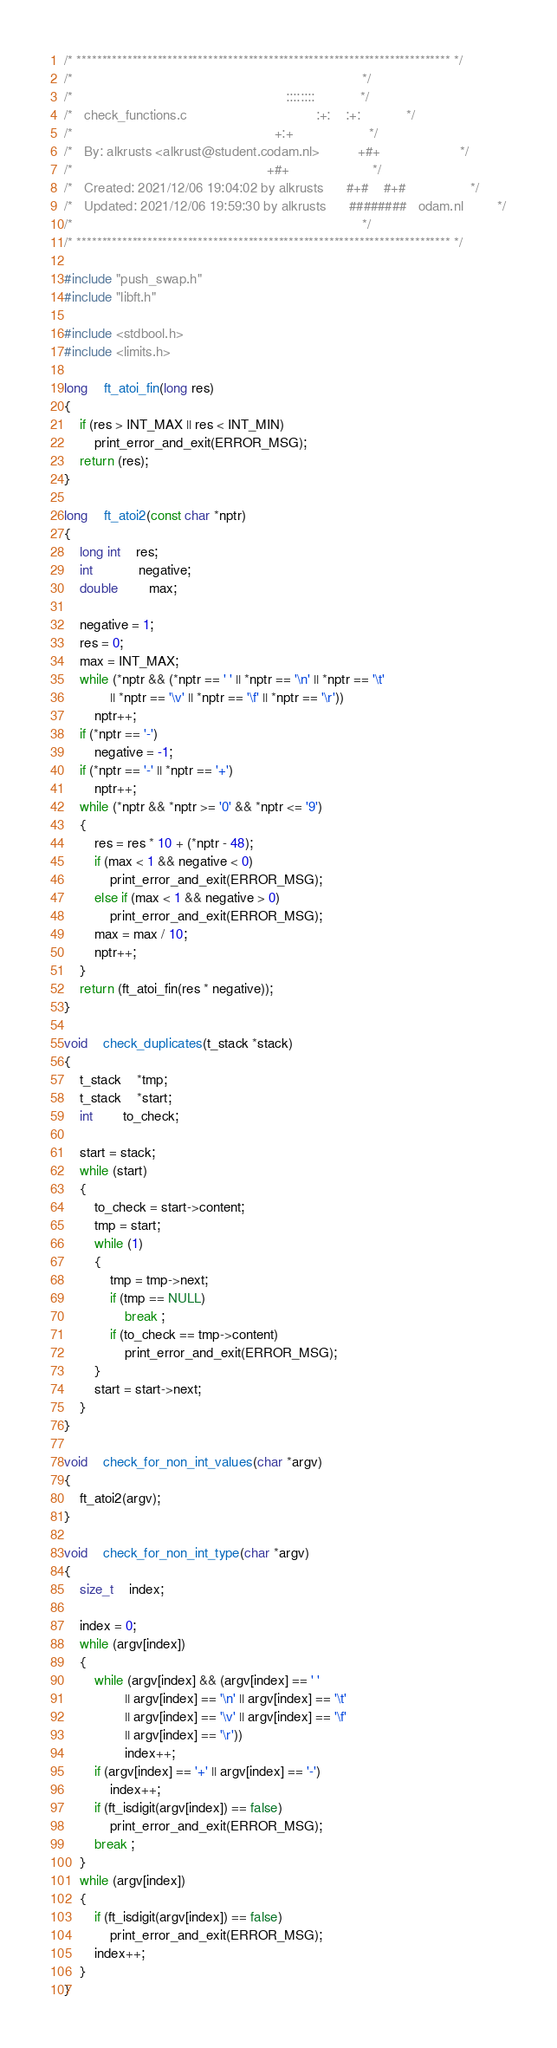Convert code to text. <code><loc_0><loc_0><loc_500><loc_500><_C_>/* ************************************************************************** */
/*                                                                            */
/*                                                        ::::::::            */
/*   check_functions.c                                  :+:    :+:            */
/*                                                     +:+                    */
/*   By: alkrusts <alkrust@student.codam.nl>          +#+                     */
/*                                                   +#+                      */
/*   Created: 2021/12/06 19:04:02 by alkrusts      #+#    #+#                 */
/*   Updated: 2021/12/06 19:59:30 by alkrusts      ########   odam.nl         */
/*                                                                            */
/* ************************************************************************** */

#include "push_swap.h"
#include "libft.h"

#include <stdbool.h>
#include <limits.h>

long	ft_atoi_fin(long res)
{
	if (res > INT_MAX || res < INT_MIN)
		print_error_and_exit(ERROR_MSG);
	return (res);
}

long	ft_atoi2(const char *nptr)
{
	long int	res;
	int			negative;
	double		max;

	negative = 1;
	res = 0;
	max = INT_MAX;
	while (*nptr && (*nptr == ' ' || *nptr == '\n' || *nptr == '\t'
			|| *nptr == '\v' || *nptr == '\f' || *nptr == '\r'))
		nptr++;
	if (*nptr == '-')
		negative = -1;
	if (*nptr == '-' || *nptr == '+')
		nptr++;
	while (*nptr && *nptr >= '0' && *nptr <= '9')
	{
		res = res * 10 + (*nptr - 48);
		if (max < 1 && negative < 0)
			print_error_and_exit(ERROR_MSG);
		else if (max < 1 && negative > 0)
			print_error_and_exit(ERROR_MSG);
		max = max / 10;
		nptr++;
	}
	return (ft_atoi_fin(res * negative));
}

void	check_duplicates(t_stack *stack)
{
	t_stack	*tmp;
	t_stack	*start;
	int		to_check;

	start = stack;
	while (start)
	{
		to_check = start->content;
		tmp = start;
		while (1)
		{
			tmp = tmp->next;
			if (tmp == NULL)
				break ;
			if (to_check == tmp->content)
				print_error_and_exit(ERROR_MSG);
		}
		start = start->next;
	}
}

void	check_for_non_int_values(char *argv)
{
	ft_atoi2(argv);
}

void	check_for_non_int_type(char *argv)
{
	size_t	index;

	index = 0;
	while (argv[index])
	{
		while (argv[index] && (argv[index] == ' '
				|| argv[index] == '\n' || argv[index] == '\t'
				|| argv[index] == '\v' || argv[index] == '\f'
				|| argv[index] == '\r'))
				index++;
		if (argv[index] == '+' || argv[index] == '-')
			index++;
		if (ft_isdigit(argv[index]) == false)
			print_error_and_exit(ERROR_MSG);
		break ;
	}
	while (argv[index])
	{
		if (ft_isdigit(argv[index]) == false)
			print_error_and_exit(ERROR_MSG);
		index++;
	}
}
</code> 